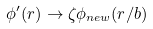Convert formula to latex. <formula><loc_0><loc_0><loc_500><loc_500>\phi ^ { \prime } ( { r } ) \rightarrow \zeta \phi _ { n e w } ( { r } / b )</formula> 